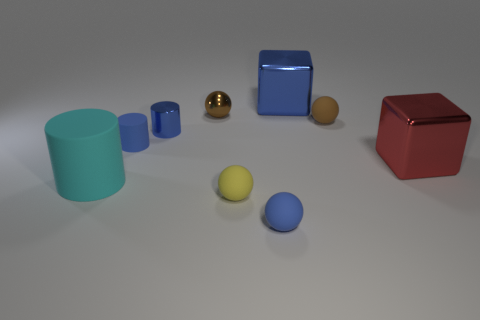Does the small metallic object that is right of the tiny blue metal thing have the same color as the small rubber thing behind the small rubber cylinder?
Provide a succinct answer. Yes. There is another tiny cylinder that is the same color as the small rubber cylinder; what material is it?
Ensure brevity in your answer.  Metal. The small metal thing to the left of the brown thing that is left of the blue matte ball is what color?
Offer a very short reply. Blue. Are there any matte spheres of the same color as the metal ball?
Your answer should be very brief. Yes. There is a red metallic object that is the same size as the cyan cylinder; what shape is it?
Your answer should be compact. Cube. There is a tiny blue metallic cylinder that is left of the blue metallic block; what number of objects are on the right side of it?
Your response must be concise. 6. Is the small matte cylinder the same color as the small metallic cylinder?
Provide a short and direct response. Yes. What number of other things are there of the same material as the big red block
Provide a succinct answer. 3. What is the shape of the tiny blue object that is behind the blue matte object that is left of the tiny yellow matte thing?
Give a very brief answer. Cylinder. How big is the blue object that is in front of the large cyan rubber object?
Offer a terse response. Small. 